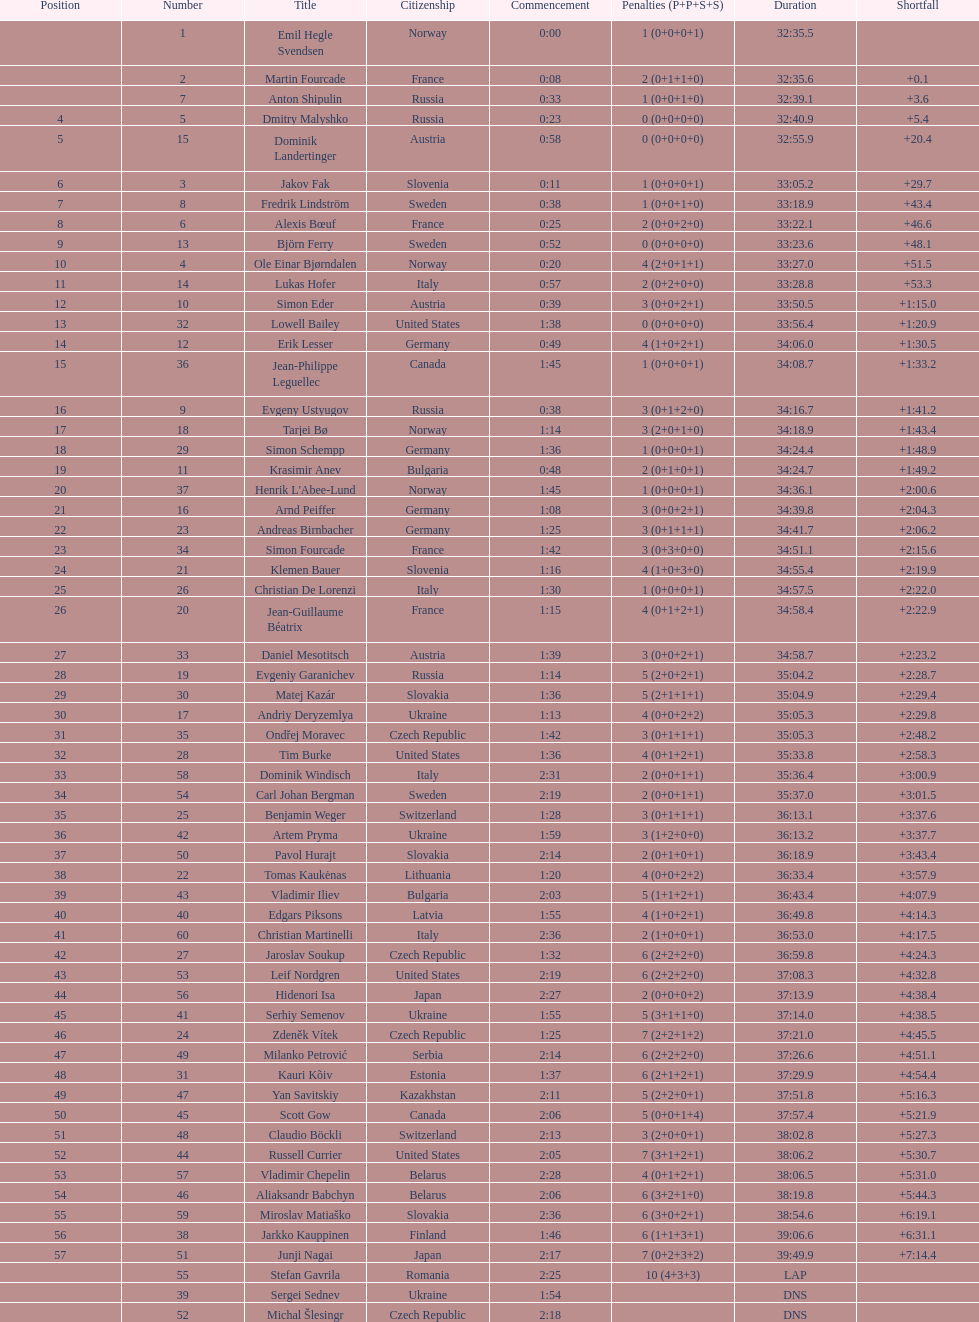How long did it take for erik lesser to finish? 34:06.0. 